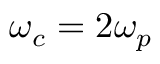<formula> <loc_0><loc_0><loc_500><loc_500>\omega _ { c } = 2 \omega _ { p }</formula> 